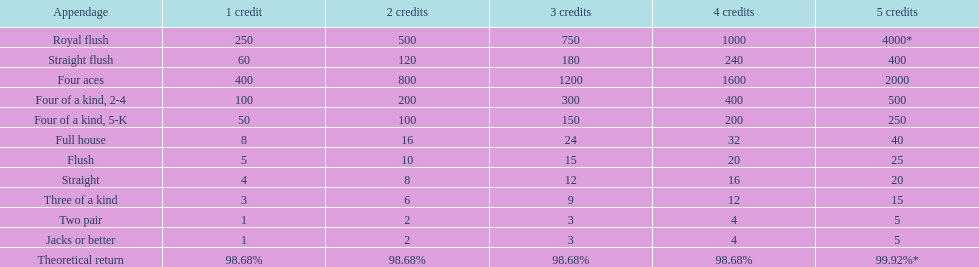Is a 2 credit full house the same as a 5 credit three of a kind? No. 